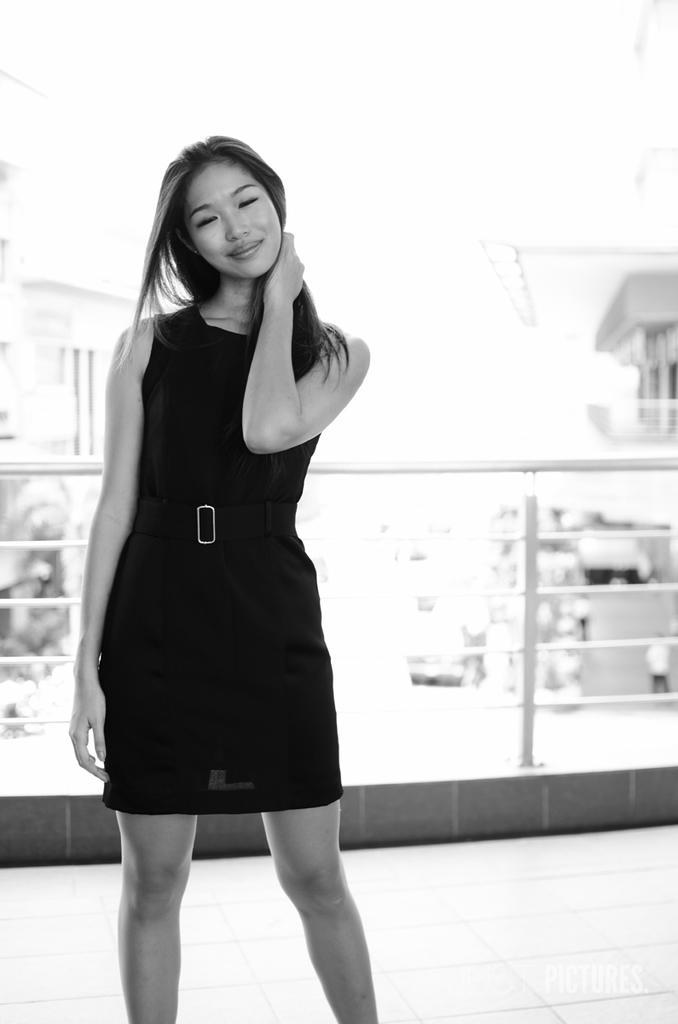Describe this image in one or two sentences. There is a woman in a dress, smiling and standing on a floor. In the background, there is a fence and there are buildings. And the background is white in color. 